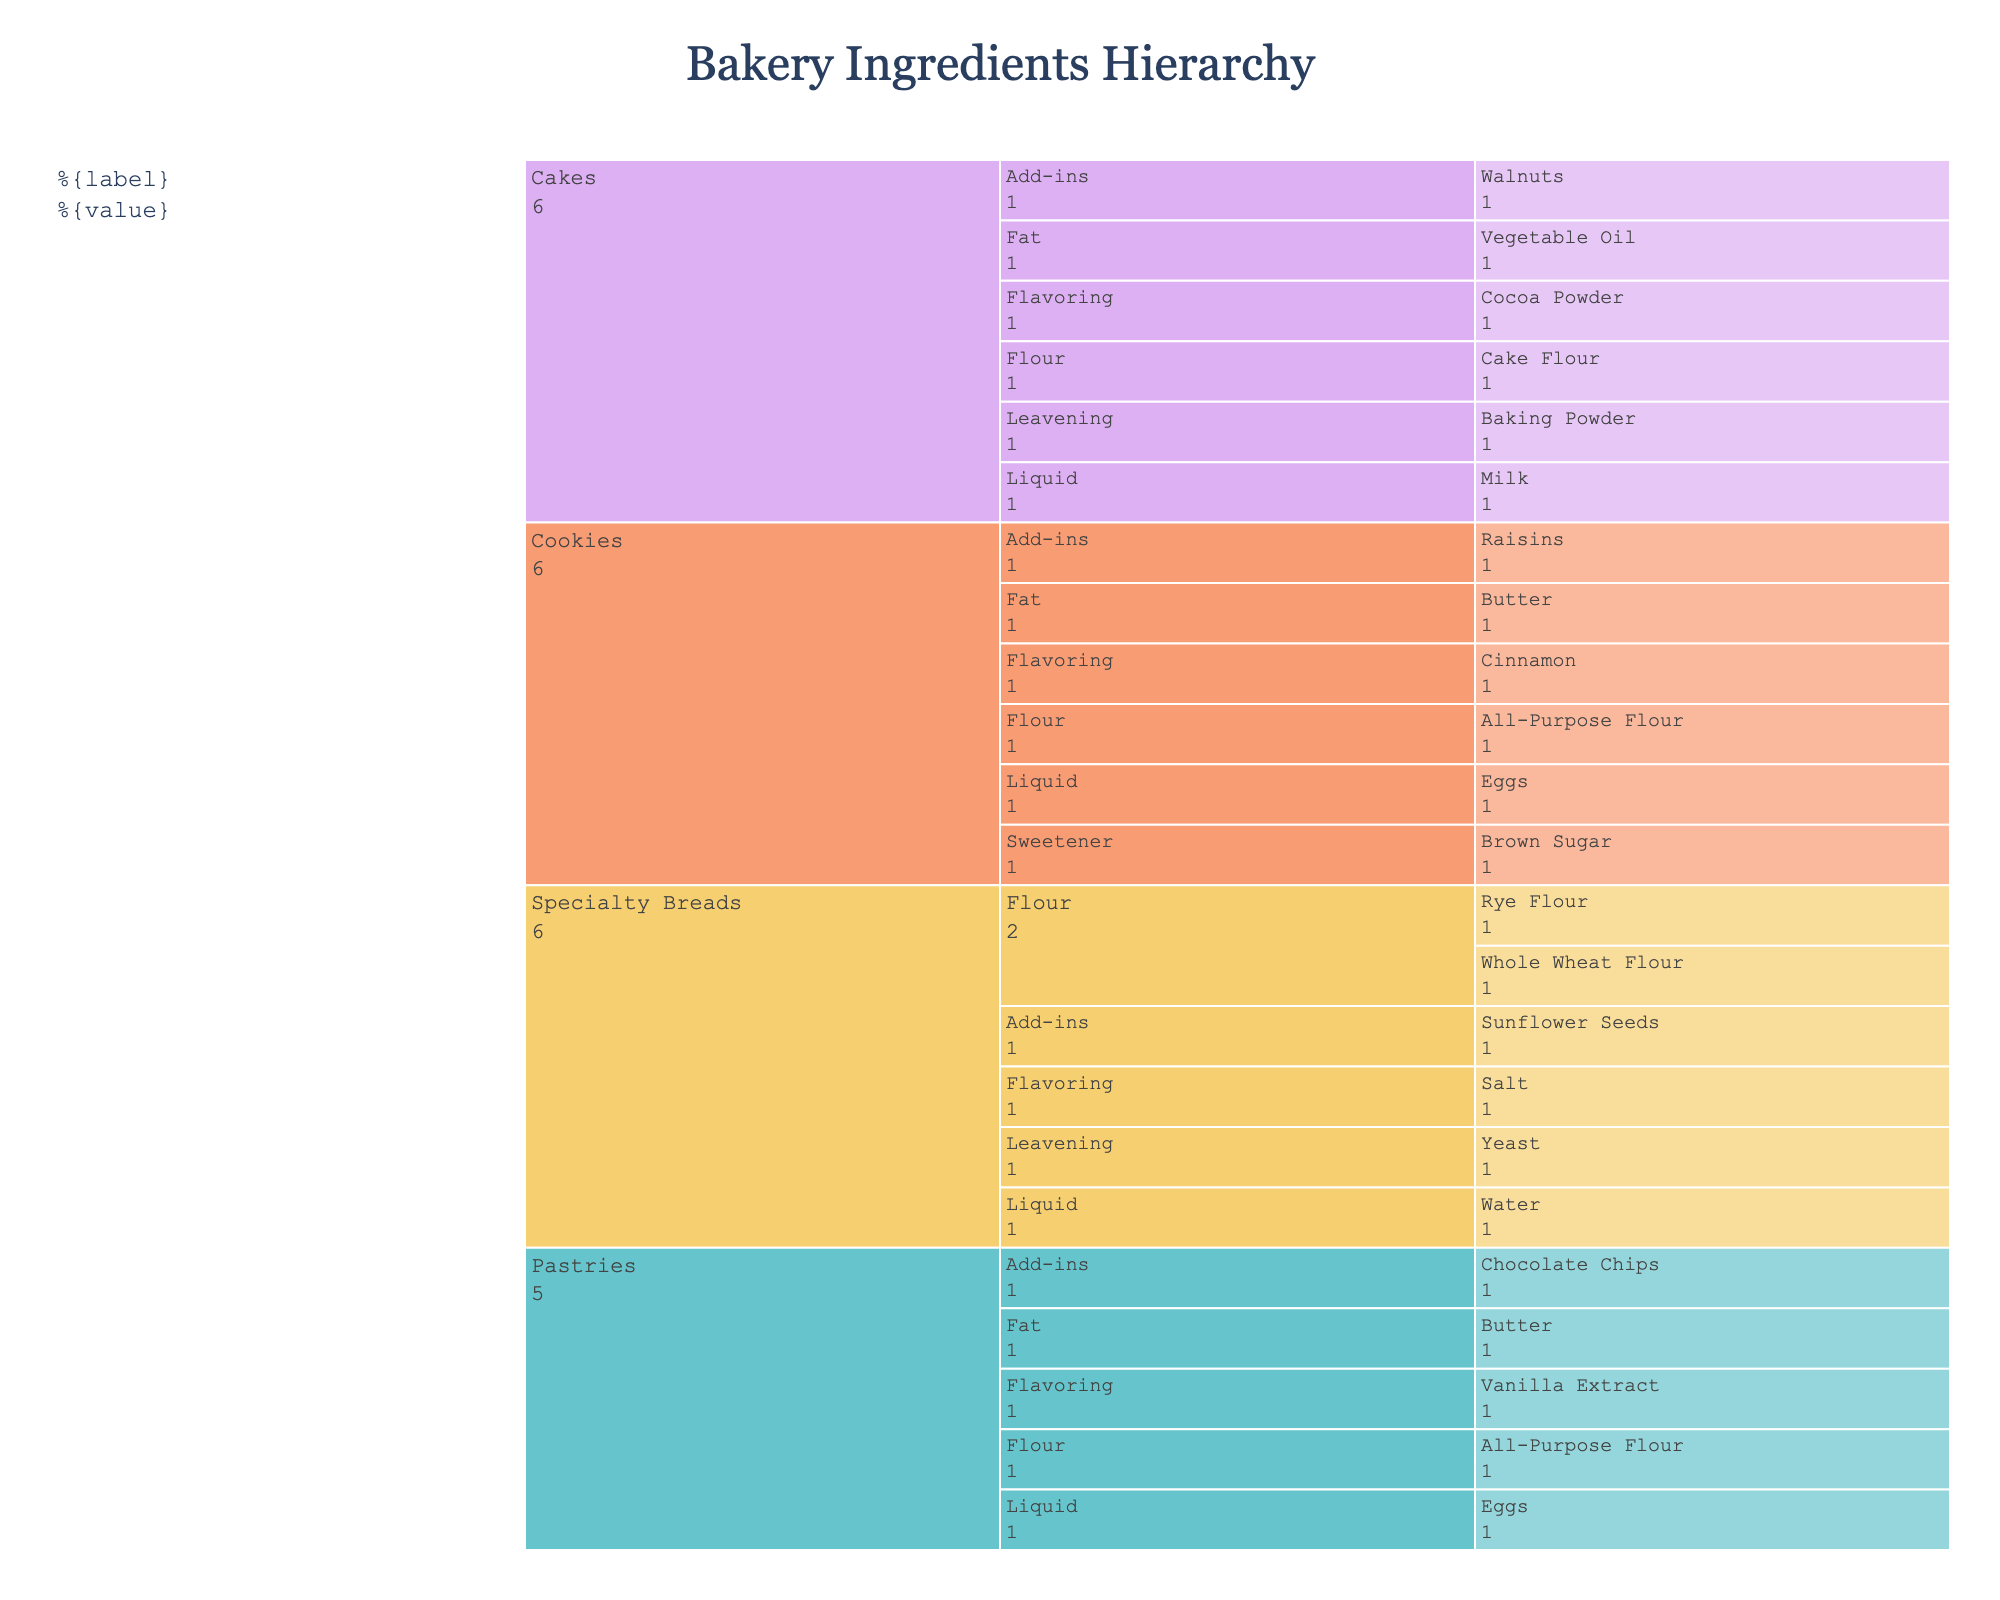What types of recipes are displayed in the chart? The icicle chart categorizes ingredients based on recipe types, which are listed at the highest level of the hierarchy. By analyzing the chart, one can observe the recipe categories mentioned.
Answer: Specialty Breads, Pastries, Cakes, Cookies Which ingredient category has the most types of ingredients listed under "Specialty Breads"? The chart can be examined to count the number of unique ingredients falling under each ingredient category within the "Specialty Breads" section.
Answer: Flour (2 types) How many total ingredients are listed in the "Pastries" section? By counting all the individual ingredients under the "Pastries" section in the icicle chart, one can determine the total number of ingredients.
Answer: 5 What is the total number of add-in ingredients across all recipe types? To find the total number of add-in ingredients, sum the number of add-in ingredients listed under each recipe type in the icicle chart.
Answer: 4 Which ingredient has the smallest quantity in the "Cakes" section? By examining the quantities along each ingredient in the "Cakes" section, one can identify the ingredient with the least quantity.
Answer: Baking Powder (10g) How does the liquid quantity for "Cakes" compare to the liquid quantity for "Specialty Breads"? Comparing the liquids listed under "Cakes" and "Specialty Breads" and summing up the quantities for each to determine the larger quantity.
Answer: Specialty Breads have 400ml water; Cakes have 250ml milk. Specialty Breads have more liquid Which type of flour is used across the most variety of recipes? By scanning the chart for different types of flour and counting how often each type appears under various recipe types, one can determine the most prevalent flour type.
Answer: All-Purpose Flour (used in Pastries and Cookies) What is the sum of ingredient quantities for "Specialty Breads"? Add together all the quantities listed for each ingredient under the "Specialty Breads" section.
Answer: 500g + 250g + 15g + 400ml + 10g + 50g = 1225 units Which recipe type includes both "Butter" and "Chocolate Chips" as ingredients? Look for the recipe types that contain the listed ingredients by their categories in the chart.
Answer: Pastries Is the total quantity of liquid ingredients in "Cookies" more than in "Pastries"? Compare the sum of quantities of liquid ingredients listed under "Cookies" and "Pastries". For Cookies, the liquid is eggs; for Pastries, it is also eggs. Count the number of eggs for each.
Answer: Pastries have 3 eggs; Cookies have 2 eggs. Pastries have more liquid 